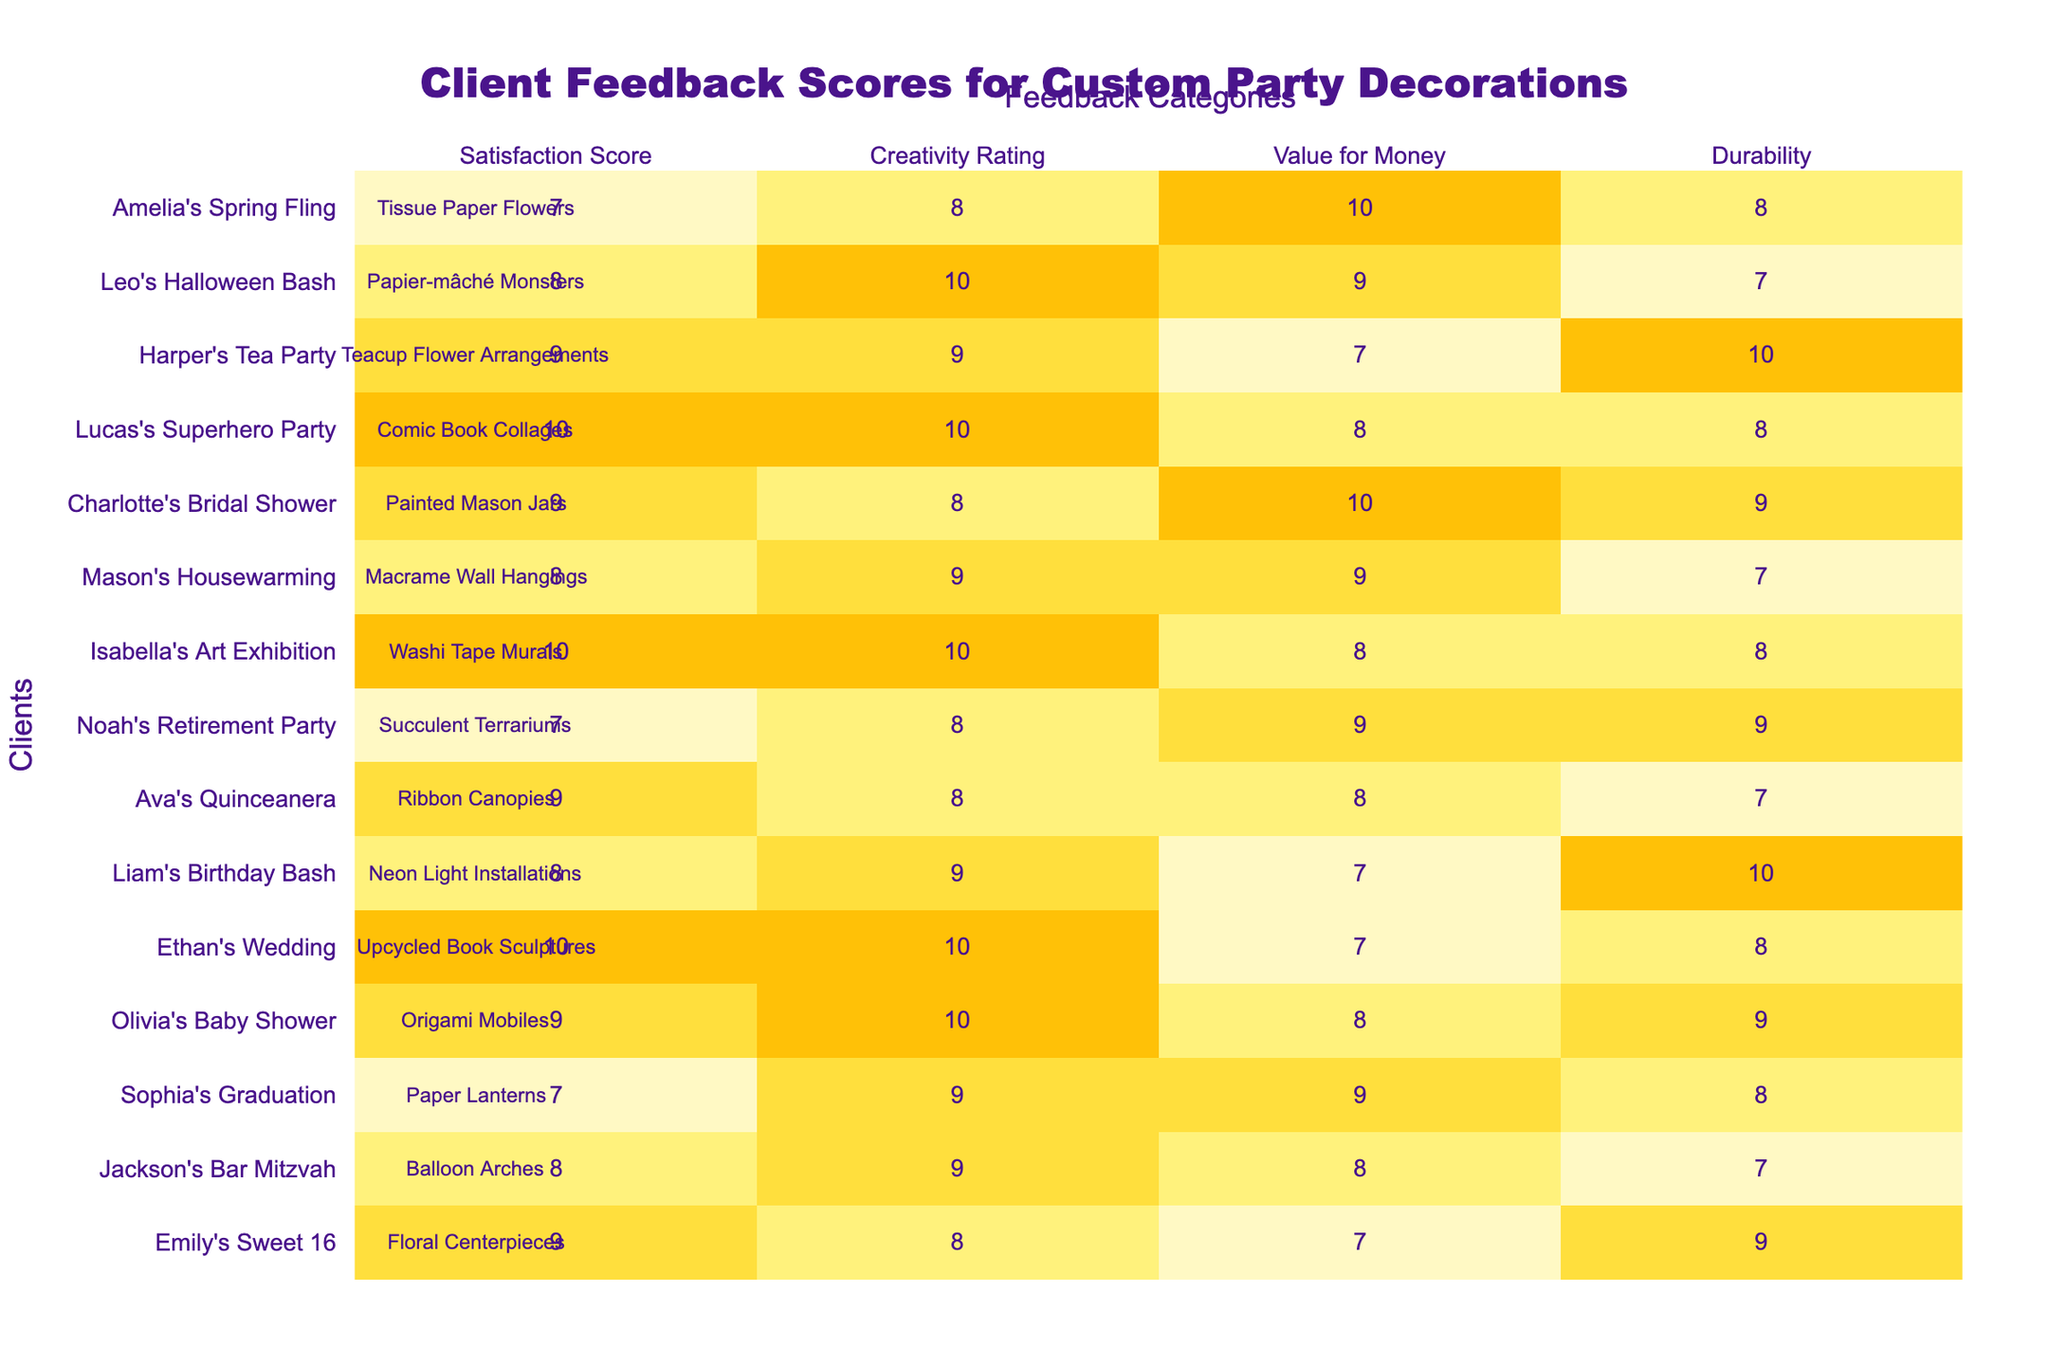What is the highest Satisfaction Score among all clients? The Satisfaction Scores listed are: 9, 8, 7, 9, 10, 8, 9, 7, 10, 8, 9, 10, 9, 8, 7. The maximum is 10.
Answer: 10 Which client had the lowest Value for Money rating? The Value for Money ratings are: 7, 8, 9, 8, 7, 7, 8, 9, 8, 9, 10, 8, 7, 10, 10. The lowest rating is 7, which belongs to multiple clients.
Answer: Emily's Sweet 16, Ethan's Wedding, Liam's Birthday Bash, Lucas's Superhero Party, and Harper's Tea Party What is the average Creativity Rating of all the decorations? The Creativity Ratings are: 8, 9, 9, 10, 10, 9, 8, 8, 10, 9, 8, 10, 9, 10, 8. Adding these gives 133, and dividing by 15 gives an average of 8.87.
Answer: 8.87 Who had the highest Durability score, and what was it? The Durability scores are: 9, 7, 8, 9, 8, 10, 7, 9, 8, 7, 9, 8, 10, 7, 8. The highest score is 10, which belongs to Liam's Birthday Bash and Harper's Tea Party.
Answer: Liam's Birthday Bash and Harper's Tea Party, 10 Is there any client with a Satisfaction Score of 7? Yes, there are clients with Satisfaction Scores of 7, which are Sophia's Graduation, Noah's Retirement Party, and Amelia's Spring Fling.
Answer: Yes What is the difference between the highest and lowest Creativity Ratings? The highest Creativity Rating is 10 (Ethan's Wedding, Isabella's Art Exhibition, Lucas's Superhero Party) and the lowest is 8 (Ava's Quinceanera). The difference is 10 - 8 = 2.
Answer: 2 How many clients received a Satisfaction Score of 9 or more? The clients with Satisfaction Scores of 9 or more are Emily's Sweet 16, Olivia's Baby Shower, Ethan's Wedding, Ava's Quinceanera, Isabella's Art Exhibition, Lucas's Superhero Party, Harper's Tea Party, and Charlotte's Bridal Shower. This makes a total of 8 clients.
Answer: 8 Which decoration type received the highest overall scores in all categories? We compare overall scores across Satisfaction, Creativity, Value for Money, and Durability for each decoration type. The One with the highest total is Ethan's Wedding with 10, 10, 7, 8 (Total=35).
Answer: Upcycled Book Sculptures Is the Durability score for Neon Light Installations above the average Durability score? The Durability score for Neon Light Installations is 10. The Durability ratings are 9, 7, 8, 9, 8, 10, 7, 9, 8, 7, 9, 8, 10, 7, 8 total to 138 divided by 15 equals an average of 9.2. Since 10 > 9.2, it is above average.
Answer: Yes What is the total Satisfaction Score for all clients? The total Satisfaction Score is the sum of all individual scores, which is 9 + 8 + 7 + 9 + 10 + 8 + 9 + 7 + 10 + 8 + 9 + 10 + 9 + 8 + 7 = 138.
Answer: 138 